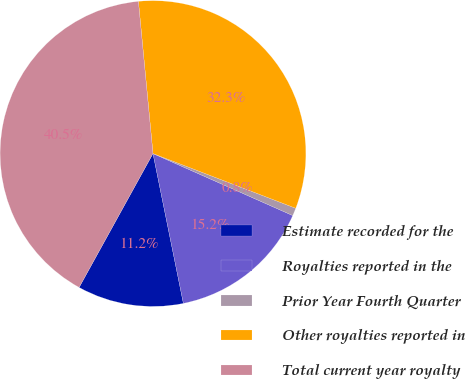Convert chart. <chart><loc_0><loc_0><loc_500><loc_500><pie_chart><fcel>Estimate recorded for the<fcel>Royalties reported in the<fcel>Prior Year Fourth Quarter<fcel>Other royalties reported in<fcel>Total current year royalty<nl><fcel>11.21%<fcel>15.17%<fcel>0.82%<fcel>32.35%<fcel>40.46%<nl></chart> 